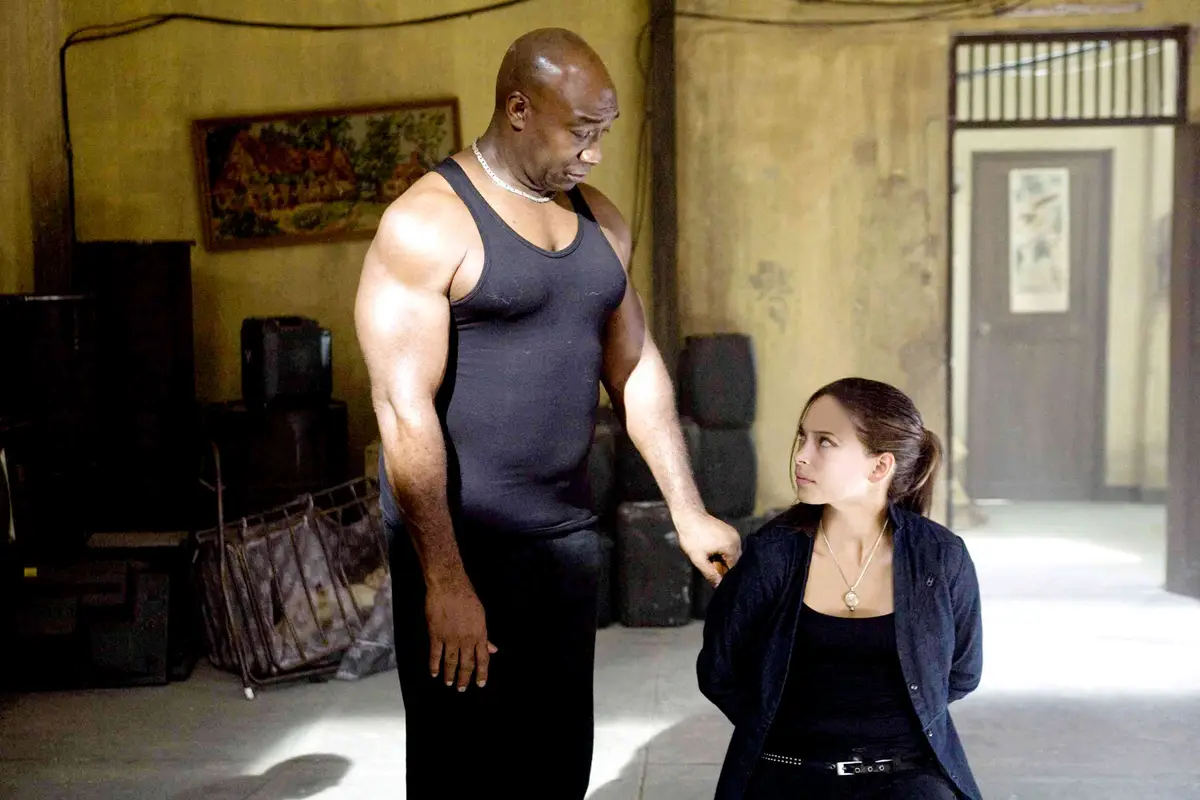How does the setting contribute to the overall mood of the image? The setting, featuring weathered walls and minimalistic, rugged furnishings, adds a sense of grittiness and realism to the image. It suggests a place that has been worn by time, paralleling the possibly hard-earned wisdom the older character might be imparting. The starkness of the room focuses the viewer's attention on the interaction between the characters, emphasizing the emotional gravity of their conversation. 